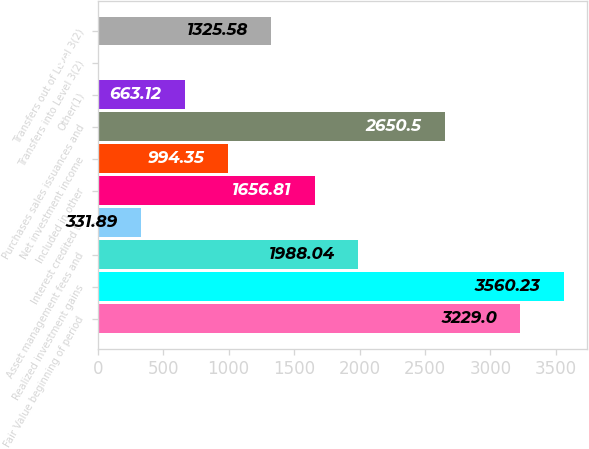Convert chart. <chart><loc_0><loc_0><loc_500><loc_500><bar_chart><fcel>Fair Value beginning of period<fcel>Realized investment gains<fcel>Asset management fees and<fcel>Interest credited to<fcel>Included in other<fcel>Net investment income<fcel>Purchases sales issuances and<fcel>Other(1)<fcel>Transfers into Level 3(2)<fcel>Transfers out of Level 3(2)<nl><fcel>3229<fcel>3560.23<fcel>1988.04<fcel>331.89<fcel>1656.81<fcel>994.35<fcel>2650.5<fcel>663.12<fcel>0.66<fcel>1325.58<nl></chart> 